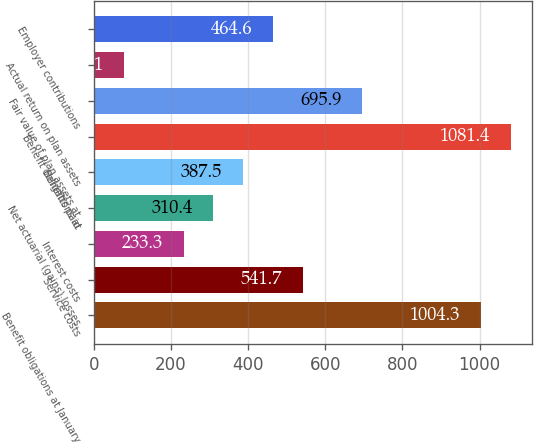Convert chart to OTSL. <chart><loc_0><loc_0><loc_500><loc_500><bar_chart><fcel>Benefit obligations at January<fcel>Service costs<fcel>Interest costs<fcel>Net actuarial (gains) losses<fcel>Benefits paid<fcel>Benefit obligations at<fcel>Fair value of plan assets at<fcel>Actual return on plan assets<fcel>Employer contributions<nl><fcel>1004.3<fcel>541.7<fcel>233.3<fcel>310.4<fcel>387.5<fcel>1081.4<fcel>695.9<fcel>79.1<fcel>464.6<nl></chart> 